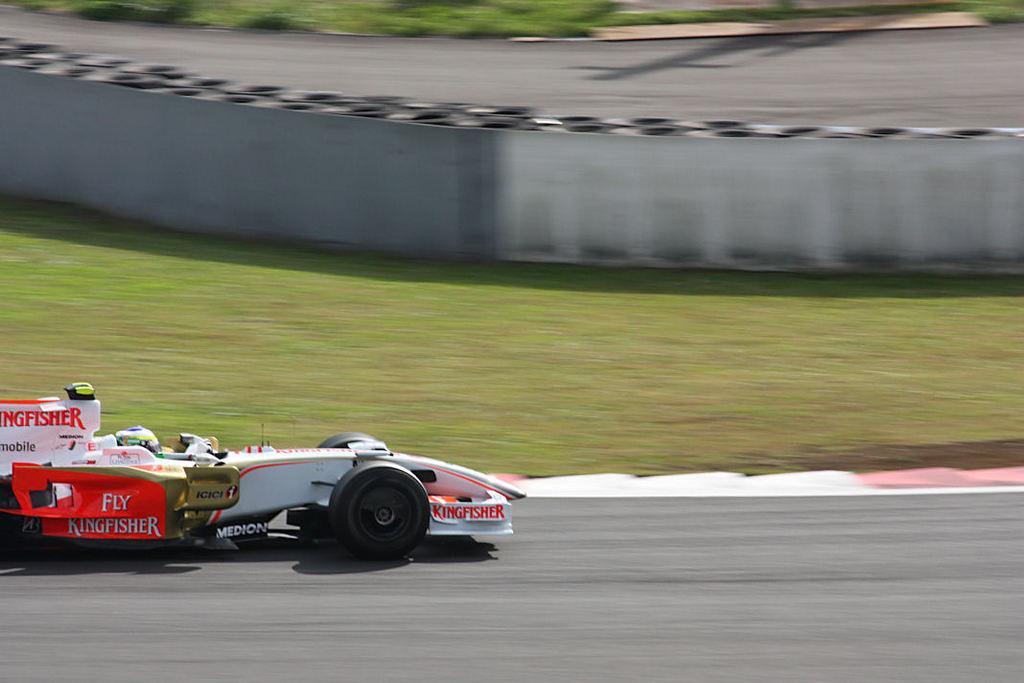Could you give a brief overview of what you see in this image? In this picture we can see a vehicle on the road and in the background we can see grass, wall, road and an object. 